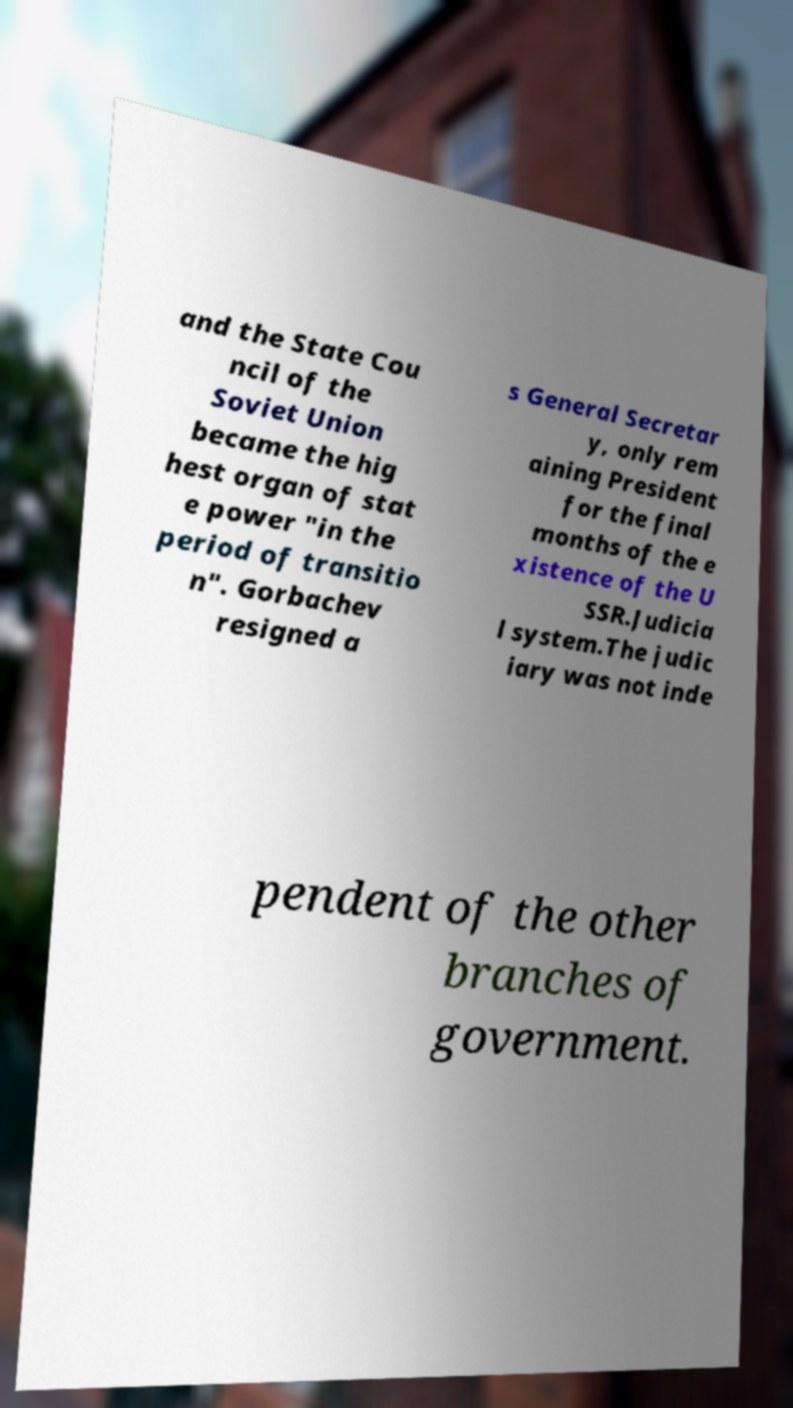Can you accurately transcribe the text from the provided image for me? and the State Cou ncil of the Soviet Union became the hig hest organ of stat e power "in the period of transitio n". Gorbachev resigned a s General Secretar y, only rem aining President for the final months of the e xistence of the U SSR.Judicia l system.The judic iary was not inde pendent of the other branches of government. 